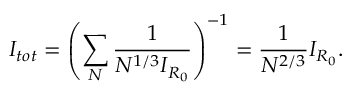<formula> <loc_0><loc_0><loc_500><loc_500>I _ { t o t } = \left ( \sum _ { N } \frac { 1 } { N ^ { 1 / 3 } I _ { R _ { 0 } } } \right ) ^ { - 1 } = \frac { 1 } { N ^ { 2 / 3 } } I _ { R _ { 0 } } .</formula> 